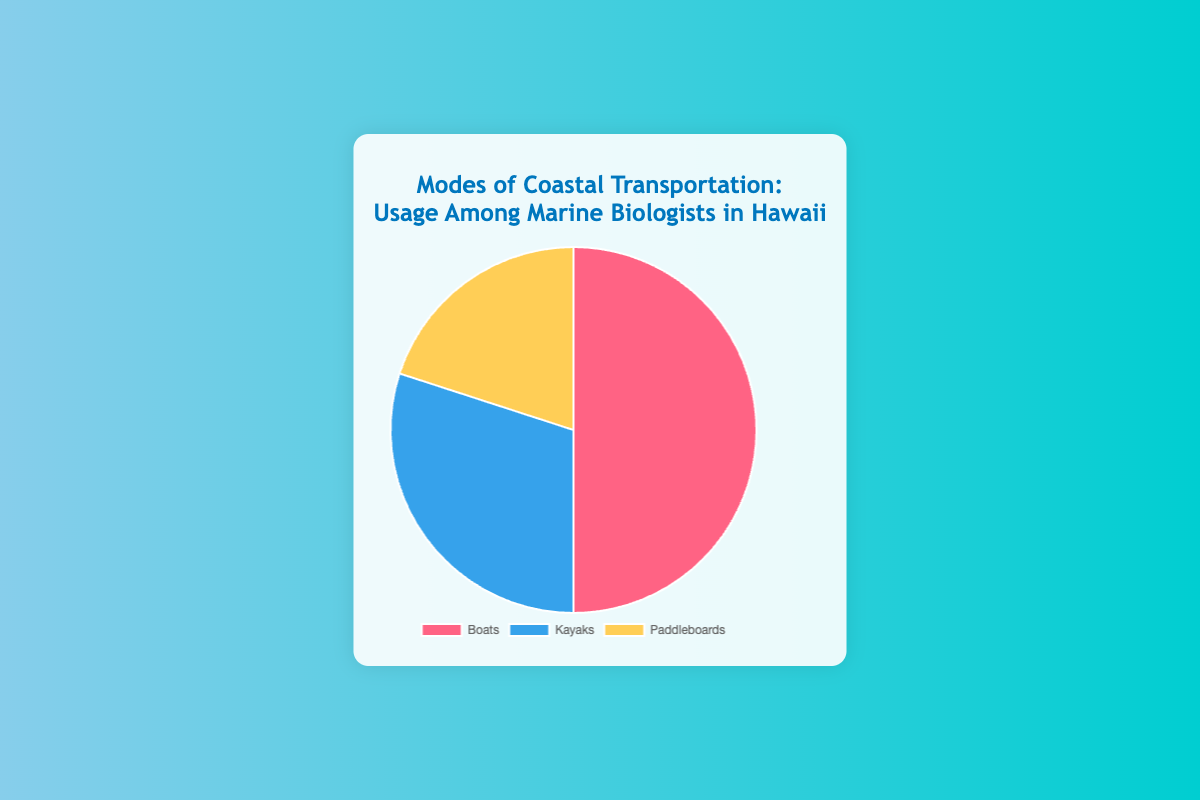Which mode of transportation is the most used among marine biologists in Hawaii? The pie chart shows three modes of transportation and their usage percentages. The mode with the highest percentage is the most used. Boats have the highest percentage at 50%.
Answer: Boats What is the total usage percentage for kayaks and paddleboards combined? We need to add the percentage of usage for both kayaks and paddleboards. The pie chart shows 30% for kayaks and 20% for paddleboards. So, the total is 30% + 20% = 50%.
Answer: 50% By how much do boats exceed kayaks in terms of usage percentage? We need to find the difference between the usage percentage of boats and kayaks. The pie chart shows 50% for boats and 30% for kayaks. So, the difference is 50% - 30% = 20%.
Answer: 20% What is the average usage percentage of all three modes of transportation? We need to find the average of the percentages of boats, kayaks, and paddleboards. The percentages are 50%, 30%, and 20% respectively. The sum is 50% + 30% + 20% = 100%. To find the average: 100% / 3 = 33.33%.
Answer: 33.33% How does the usage of paddleboards compare to that of boats? We need to compare the percentage of usage for paddleboards and boats from the pie chart. Paddleboards usage is 20% and boats usage is 50%. Since 20% is less than 50%, paddleboards have lower usage compared to boats.
Answer: Paddleboards have lower usage Which segment is represented by the yellow color in the pie chart? Looking at the pie chart, the segment with the yellow color represents paddleboards, which have a usage percentage of 20%.
Answer: Paddleboards If the marine biologists switch from paddleboards to kayaks, increasing the kayak usage by 10%, what would be the new percentage for kayaks? If paddleboard usage decreases by 10%, it goes from 20% to 10%. Adding this 10% to the current kayak usage of 30%, the new kayak usage would be 30% + 10% = 40%.
Answer: 40% What is the sum of the usage percentages of the least and most used transportation modes? The least used transportation mode is paddleboards at 20%, and the most used is boats at 50%. We need to sum these percentages: 20% + 50% = 70%.
Answer: 70% Is the combined usage percentage for kayaks and paddleboards greater than that for boats? We first find the combined usage percentage for kayaks and paddleboards, which is 30% + 20% = 50%. The boat usage percentage is also 50%. Therefore, the combined usage is equal to that for boats.
Answer: Equal 